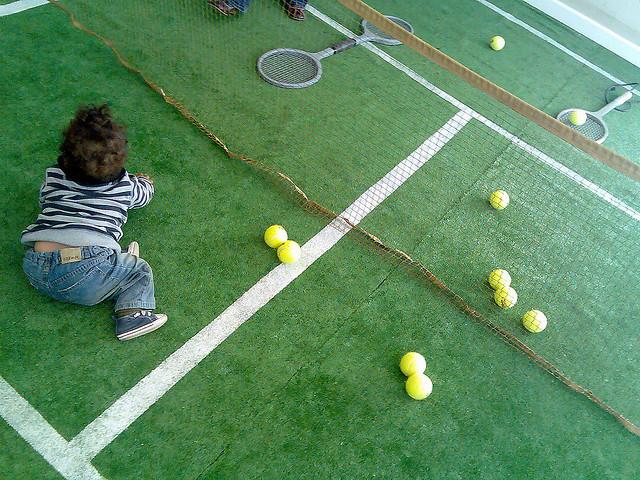Can the baby walk?
Quick response, please. No. What sport is the baby playing?
Quick response, please. Tennis. What is the least amount of people required to play this game?
Quick response, please. 2. 